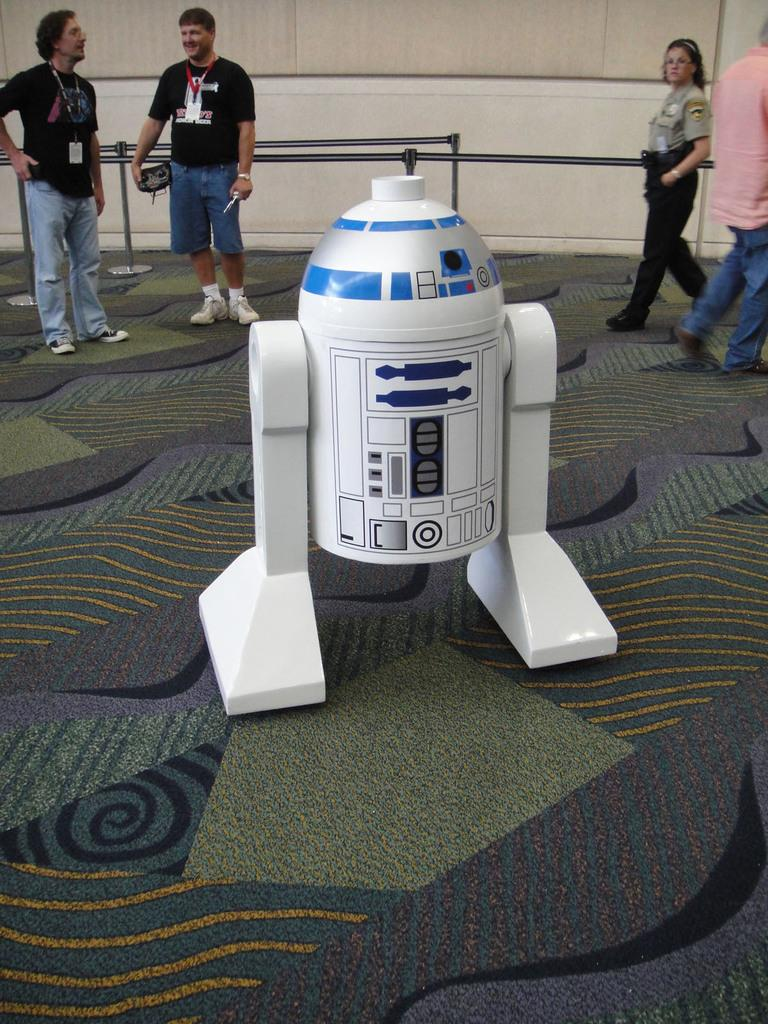What is the main object on the surface in the image? There is an object on the surface in the image, but the specific details are not provided. What can be seen in the background of the image? In the background of the image, there are people, rods with stands, and a wall. Can you describe the people in the background? The provided facts do not give specific details about the people in the background. What type of sign can be seen in the image? There is no sign present in the image. What are the girls in the image writing on the wall? There is no mention of girls or writing on the wall in the provided facts. 